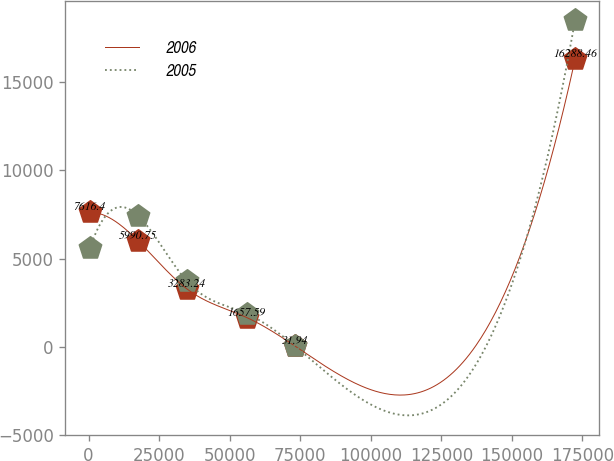Convert chart. <chart><loc_0><loc_0><loc_500><loc_500><line_chart><ecel><fcel>2006<fcel>2005<nl><fcel>395.99<fcel>7616.4<fcel>5569.85<nl><fcel>17599.2<fcel>5990.75<fcel>7416.44<nl><fcel>34802.4<fcel>3283.24<fcel>3723.26<nl><fcel>56041<fcel>1657.59<fcel>1876.67<nl><fcel>73244.2<fcel>31.94<fcel>30.08<nl><fcel>172428<fcel>16288.5<fcel>18495.9<nl></chart> 